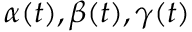Convert formula to latex. <formula><loc_0><loc_0><loc_500><loc_500>\alpha ( t ) , \beta ( t ) , \gamma ( t )</formula> 